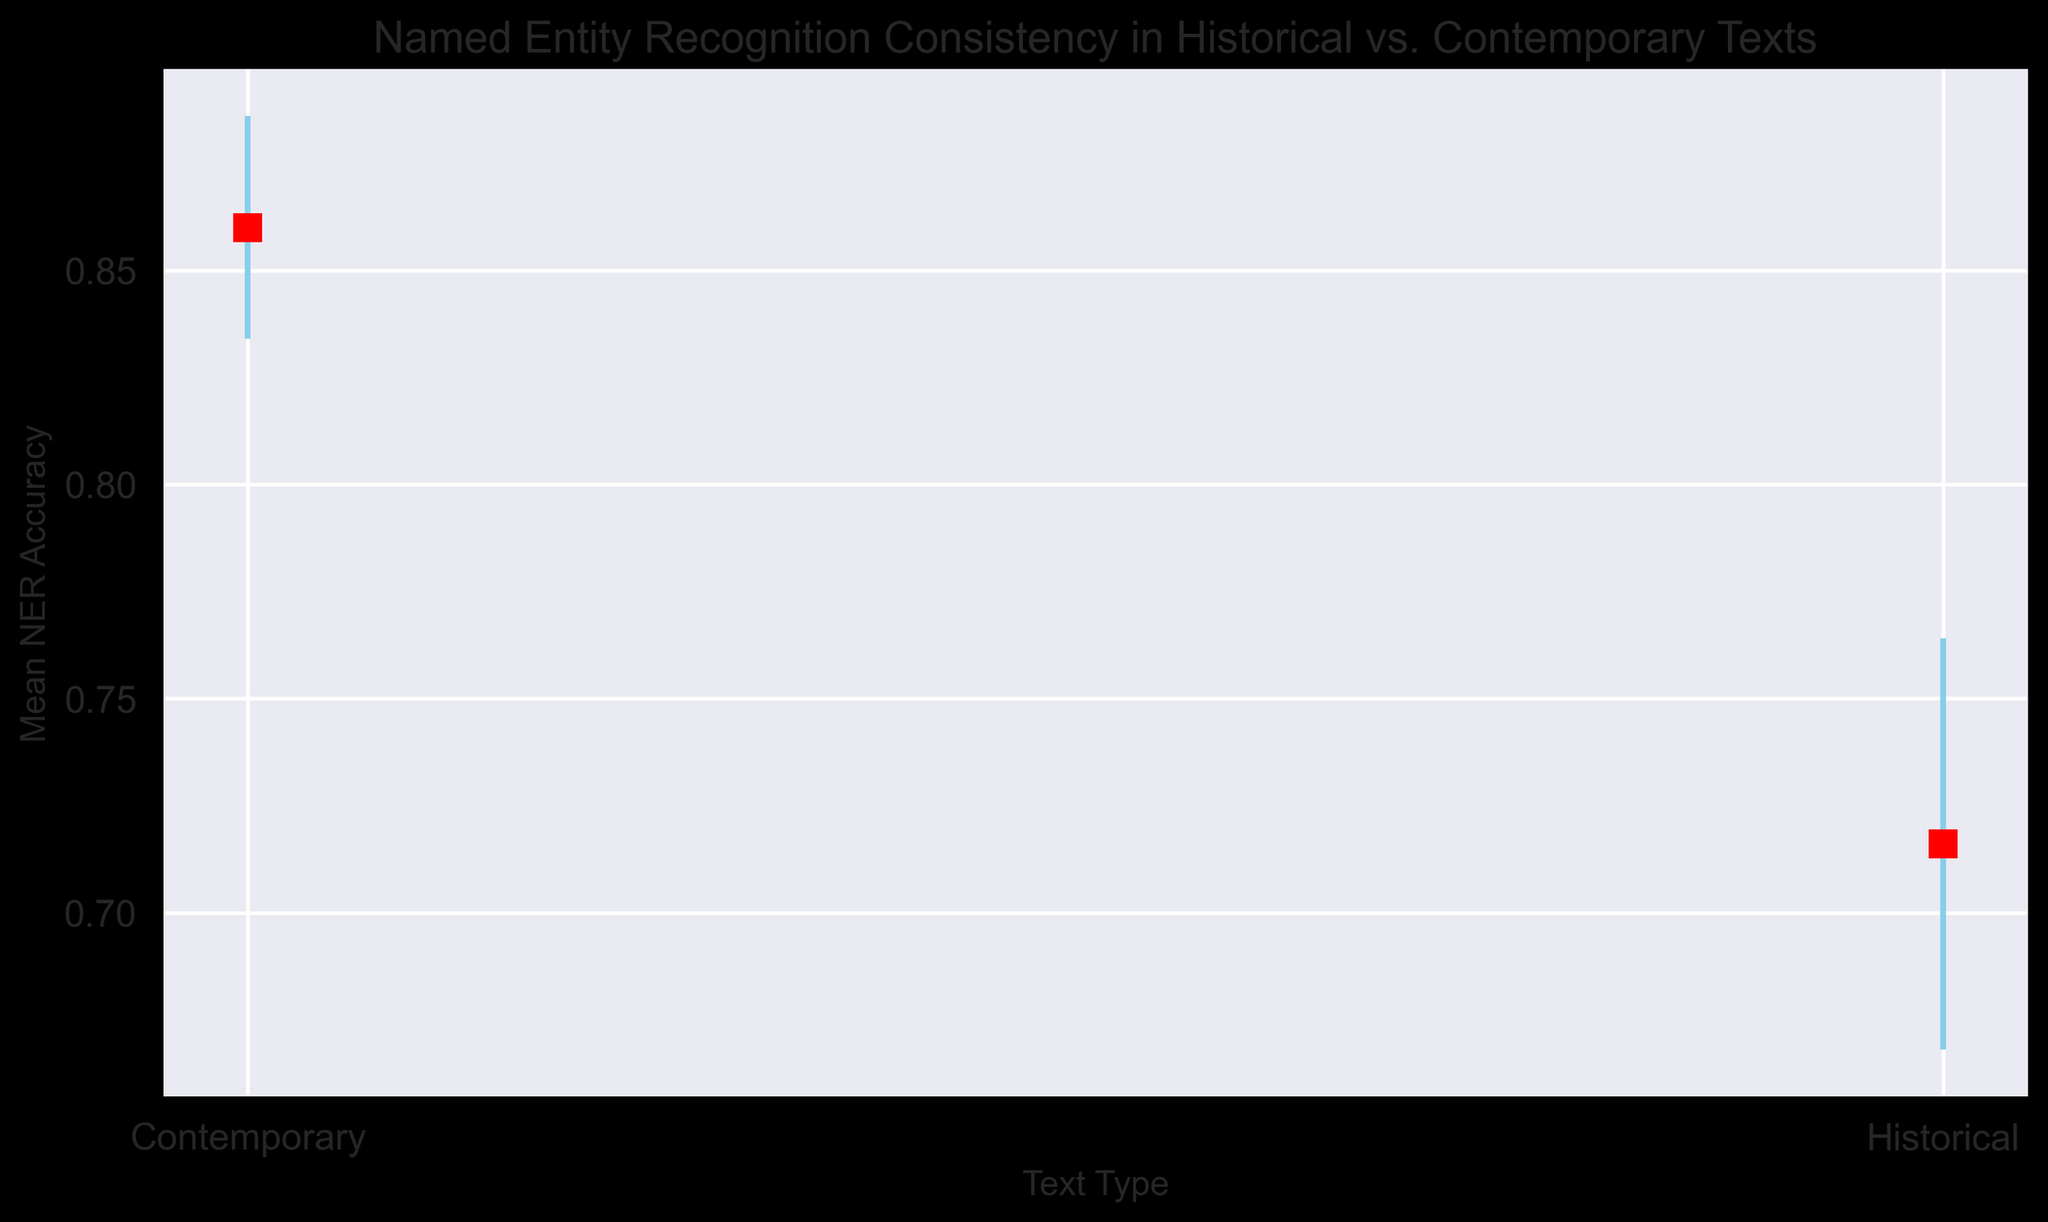What is the difference in the mean NER accuracy between contemporary and historical texts? To find the difference in mean NER accuracy between contemporary and historical texts, refer to the vertical positions of the markers on the plot. Contemporary texts have a mean NER accuracy of approximately 0.86, and historical texts have a mean NER accuracy of approximately 0.72. The difference is 0.86 - 0.72.
Answer: 0.14 Which text type has the larger standard deviation in NER accuracy? The plot shows error bars extending above and below each marker. The length of these bars represents the standard deviation. Historical texts have visibly longer error bars, indicating a larger standard deviation compared to contemporary texts.
Answer: Historical Are the mean NER accuracies for contemporary texts all higher than the mean NER accuracies for historical texts? Compare the vertical positions of the markers for each text type. The marker for contemporary texts is higher (approximately 0.86) than that for historical texts (approximately 0.72). Thus, all individual means for contemporary texts must also be higher, as they aggregate to these summary markers.
Answer: Yes Which text type shows a more consistent NER performance, and why? Consistency in performance can be inferred from the length of the error bars. Shorter error bars indicate more consistent performance. Contemporary texts have shorter error bars compared to historical texts, indicating more consistent NER performance.
Answer: Contemporary What is the average standard deviation of NER accuracy for historical texts? There are five standard deviation values for historical texts: 0.05, 0.04, 0.06, 0.05, and 0.04. Sum these values: 0.05 + 0.04 + 0.06 + 0.05 + 0.04 = 0.24. Divide by 5 to get the average: 0.24 / 5.
Answer: 0.048 By how much does the mean NER accuracy vary between the highest and lowest for historical texts? The highest mean NER accuracy for historical texts is 0.75, and the lowest is 0.68. The variation is 0.75 - 0.68.
Answer: 0.07 Which text type shows markers with red faces and black edges? Observe the markers used in the plot. The markers representing both text types are described to have red faces and black edges, so this applies to both historical and contemporary texts.
Answer: Both What is the mean NER accuracy for contemporary texts? Using the plot, find the mean NER accuracy represented by the marker for contemporary texts, which is near 0.86.
Answer: 0.86 Is the title of the plot informative about what it depicts? The title of the plot is "Named Entity Recognition Consistency in Historical vs. Contemporary Texts," clearly describing the comparison being made between the two text types concerning NER performance and consistency.
Answer: Yes 